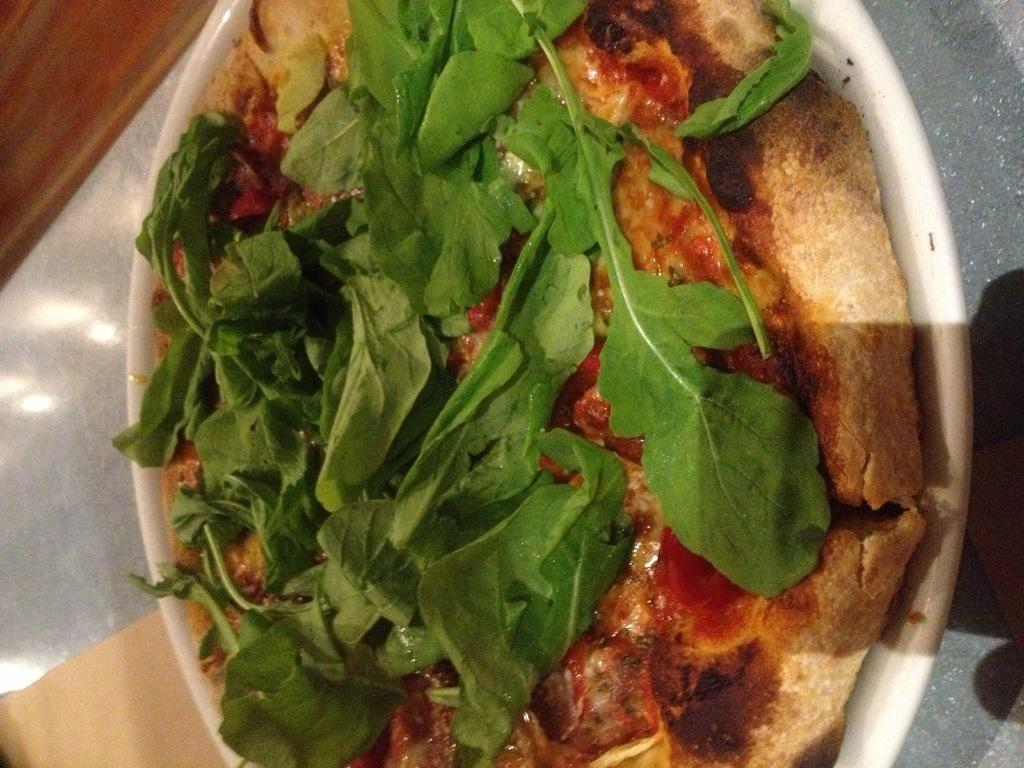What type of food is shown in the image? There is a pizza in the image. What is unique about this pizza? The pizza has leaves on it. How is the pizza presented in the image? The pizza is on a plate. Where is the plate located in relation to the table? The plate is in front of a table. What color is the ink used to write the daughter's name on the pizza? There is no daughter or ink present in the image; it only features a pizza with leaves on it. 